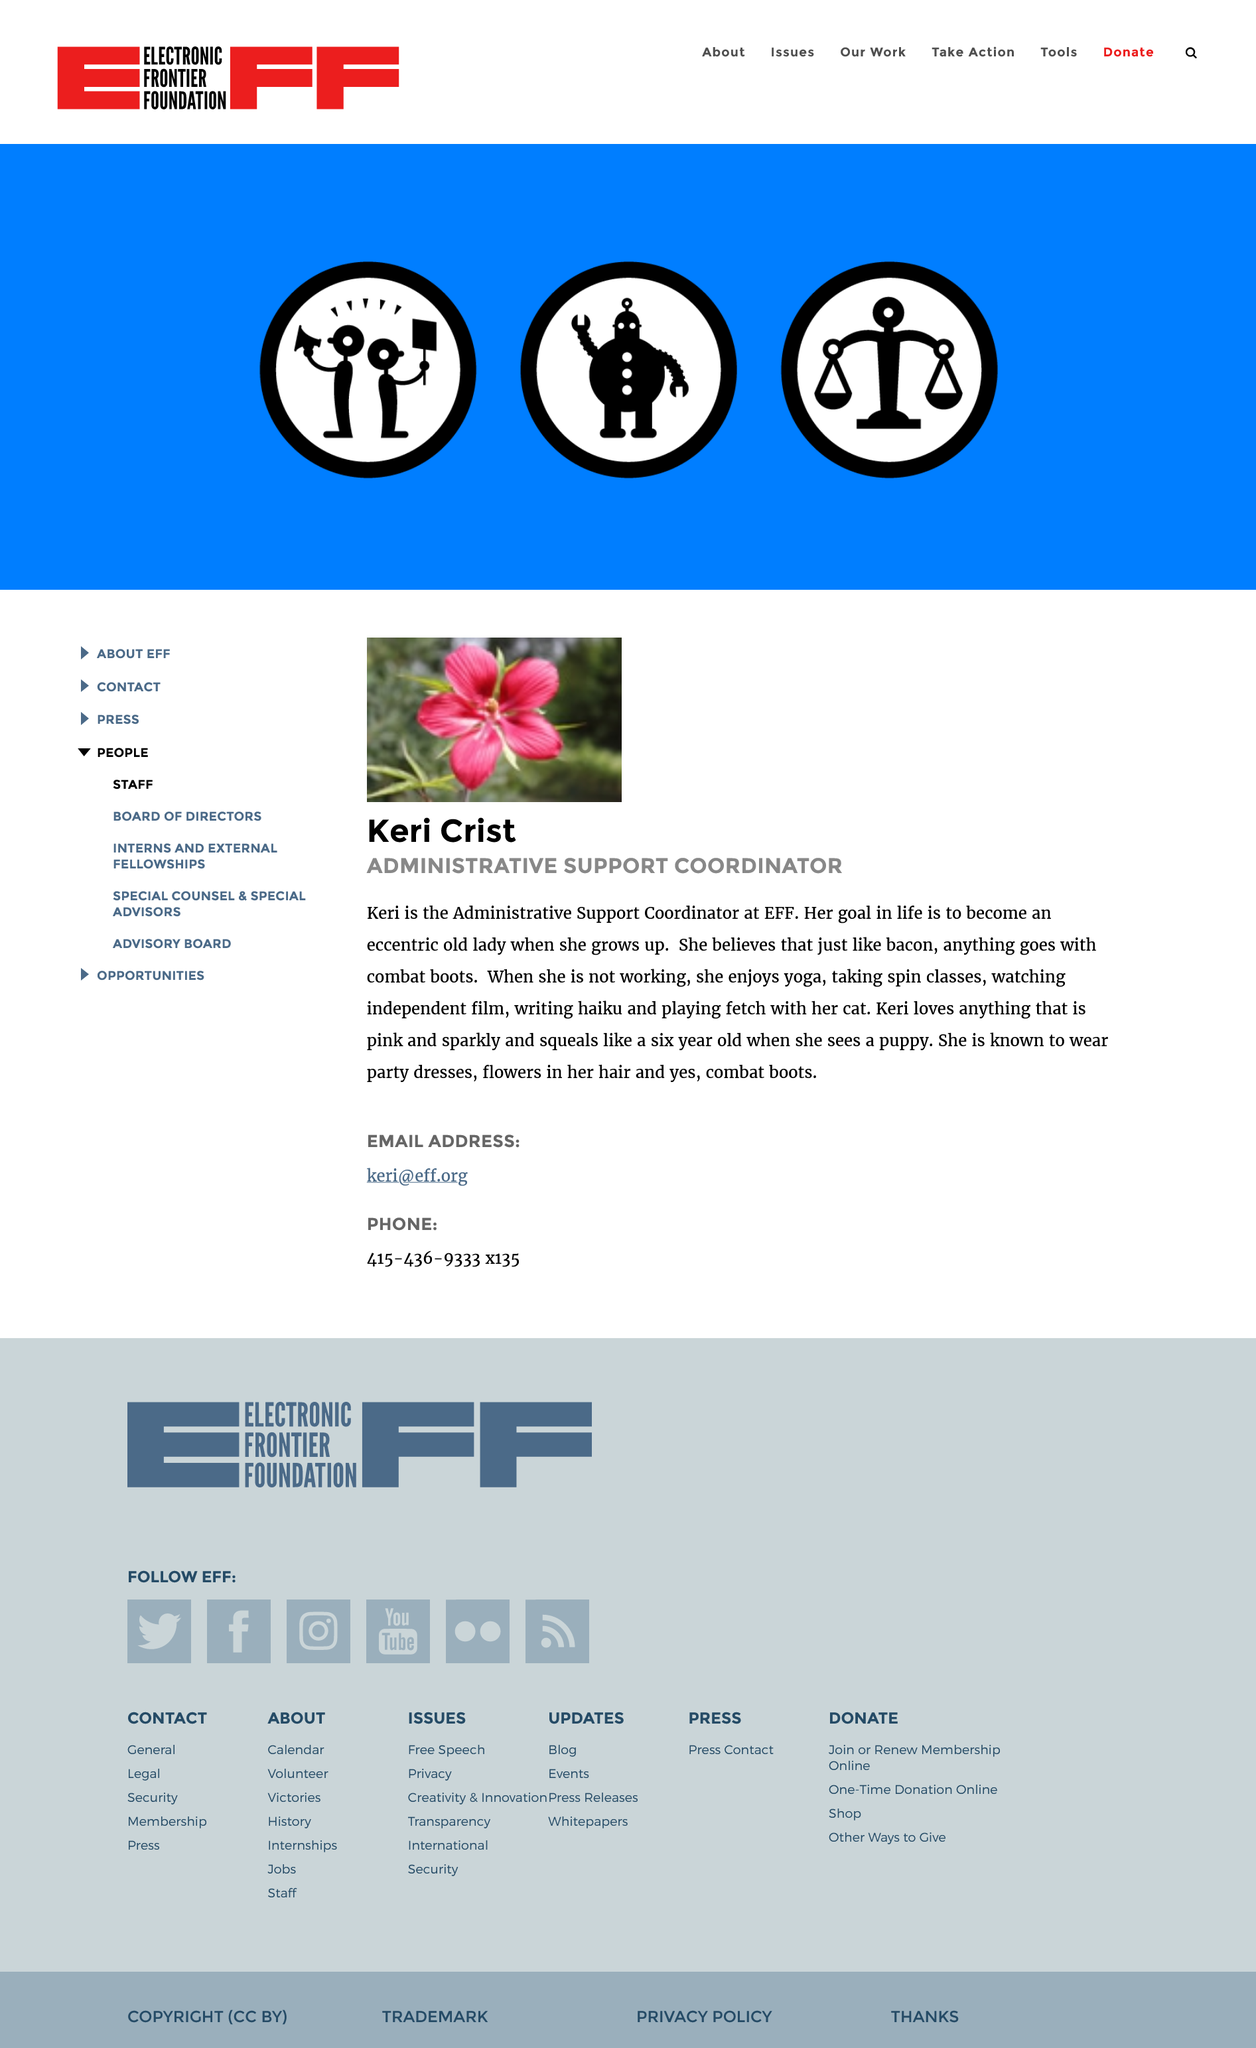Give some essential details in this illustration. Keri likes combat boots. Keri is the administrative support coordinator at her job. This page is dedicated to Keri Crist. 